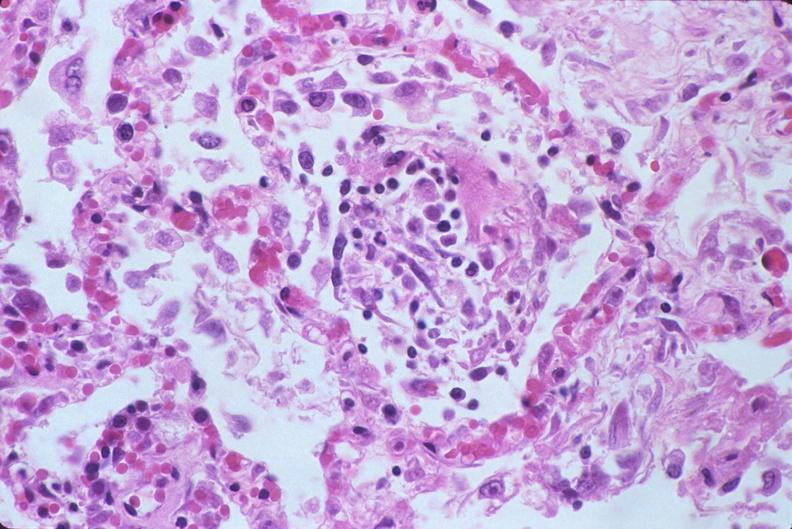what is present?
Answer the question using a single word or phrase. Respiratory 